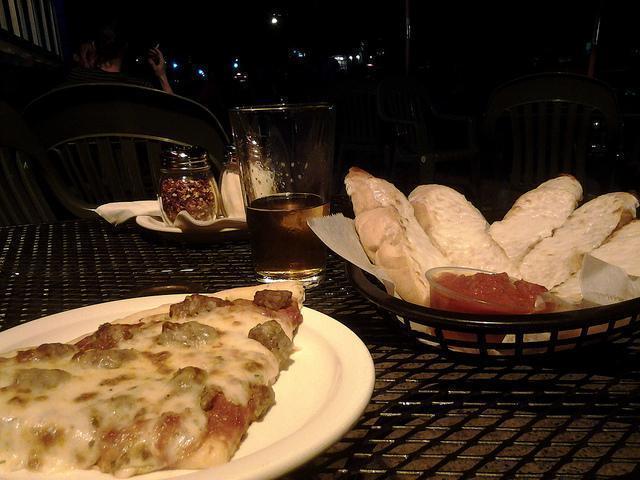What is the bread in?
Make your selection and explain in format: 'Answer: answer
Rationale: rationale.'
Options: Cats mouth, basket, box, dogs paw. Answer: basket.
Rationale: You can see the black weave under the bread - it is also curved, making it a basket. 